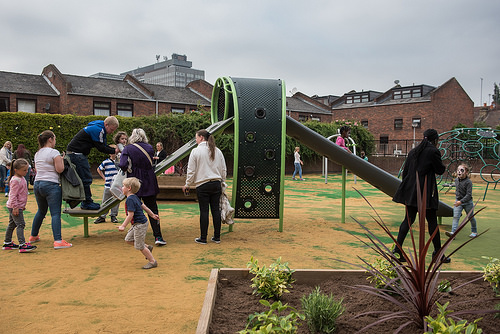<image>
Can you confirm if the ground is in front of the building? Yes. The ground is positioned in front of the building, appearing closer to the camera viewpoint. 